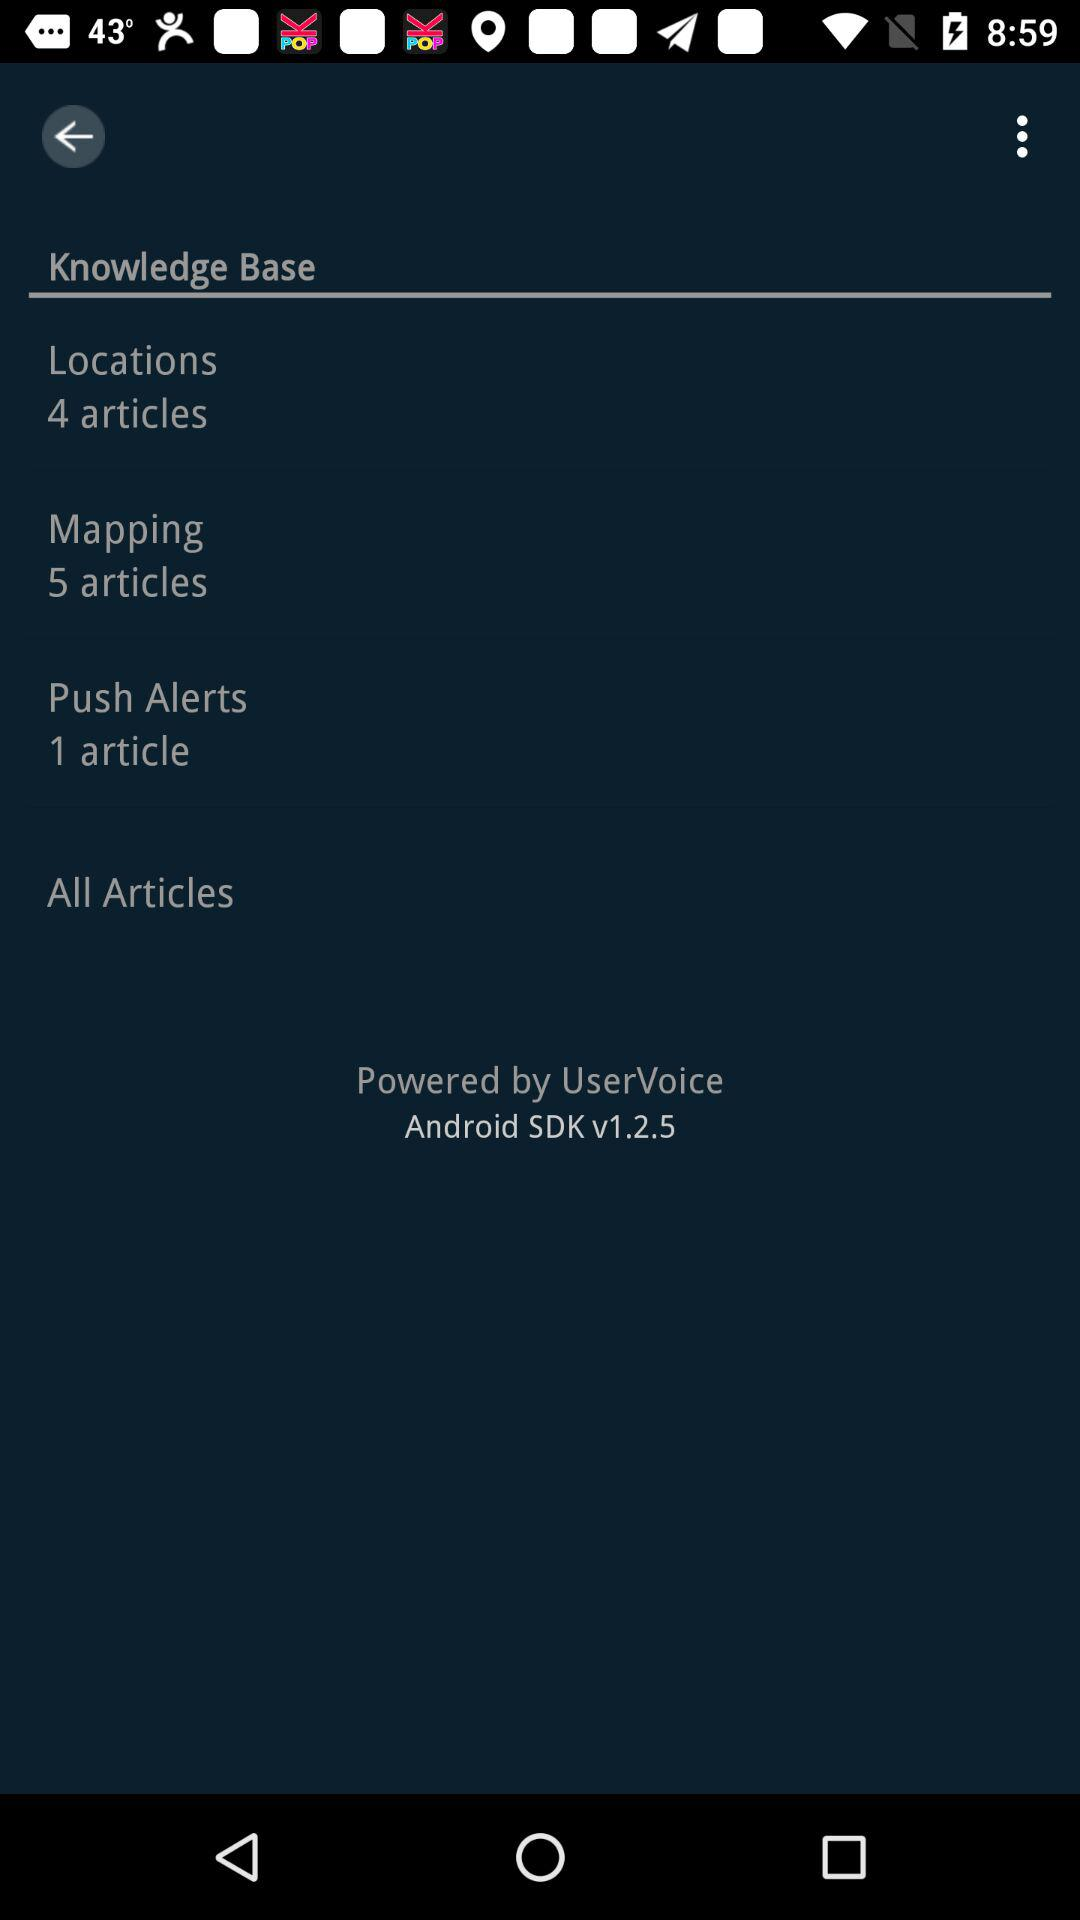What version is shown? The shown version is v1.2.5. 